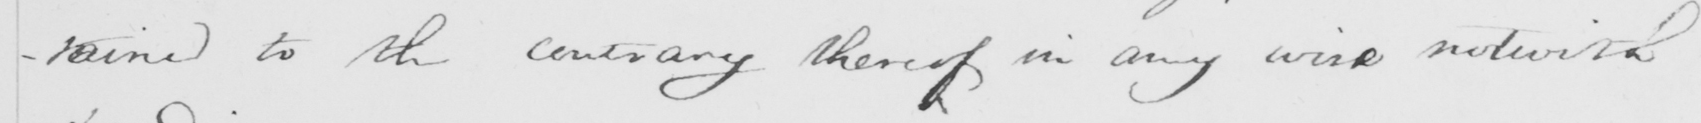Can you tell me what this handwritten text says? -tained to the contrary thereof in any wise notwith 